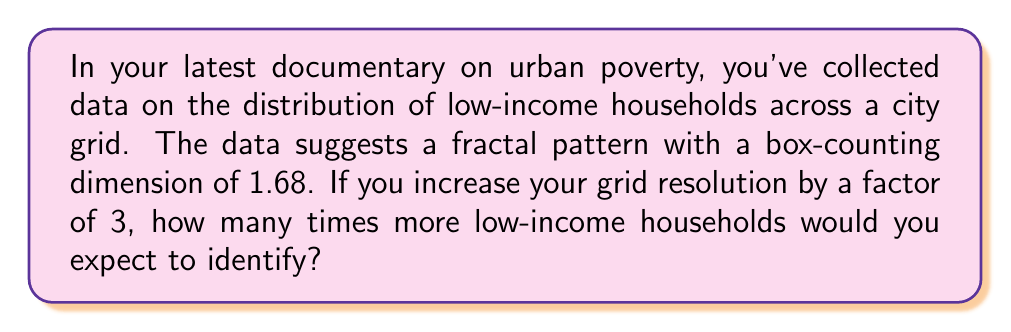Can you answer this question? To solve this problem, we need to understand the concept of fractal dimension and how it relates to scaling. The box-counting dimension (D) is given by the formula:

$$D = \frac{\log N}{\log r}$$

Where N is the number of boxes needed to cover the fractal at a given scale, and r is the scale factor.

Given:
- The fractal dimension D = 1.68
- The scale factor r = 3 (as we're increasing resolution by a factor of 3)

We want to find N, which represents how many times more households we'd expect to identify.

Step 1: Rearrange the fractal dimension formula to solve for N:
$$N = r^D$$

Step 2: Plug in the values:
$$N = 3^{1.68}$$

Step 3: Calculate the result:
$$N \approx 3.8052$$

This means that when we increase the resolution by a factor of 3, we expect to identify approximately 3.8052 times more low-income households.

This fractal analysis reveals the self-similar nature of urban poverty patterns, showing how inequality manifests across different scales in the urban landscape.
Answer: 3.8052 times more households 